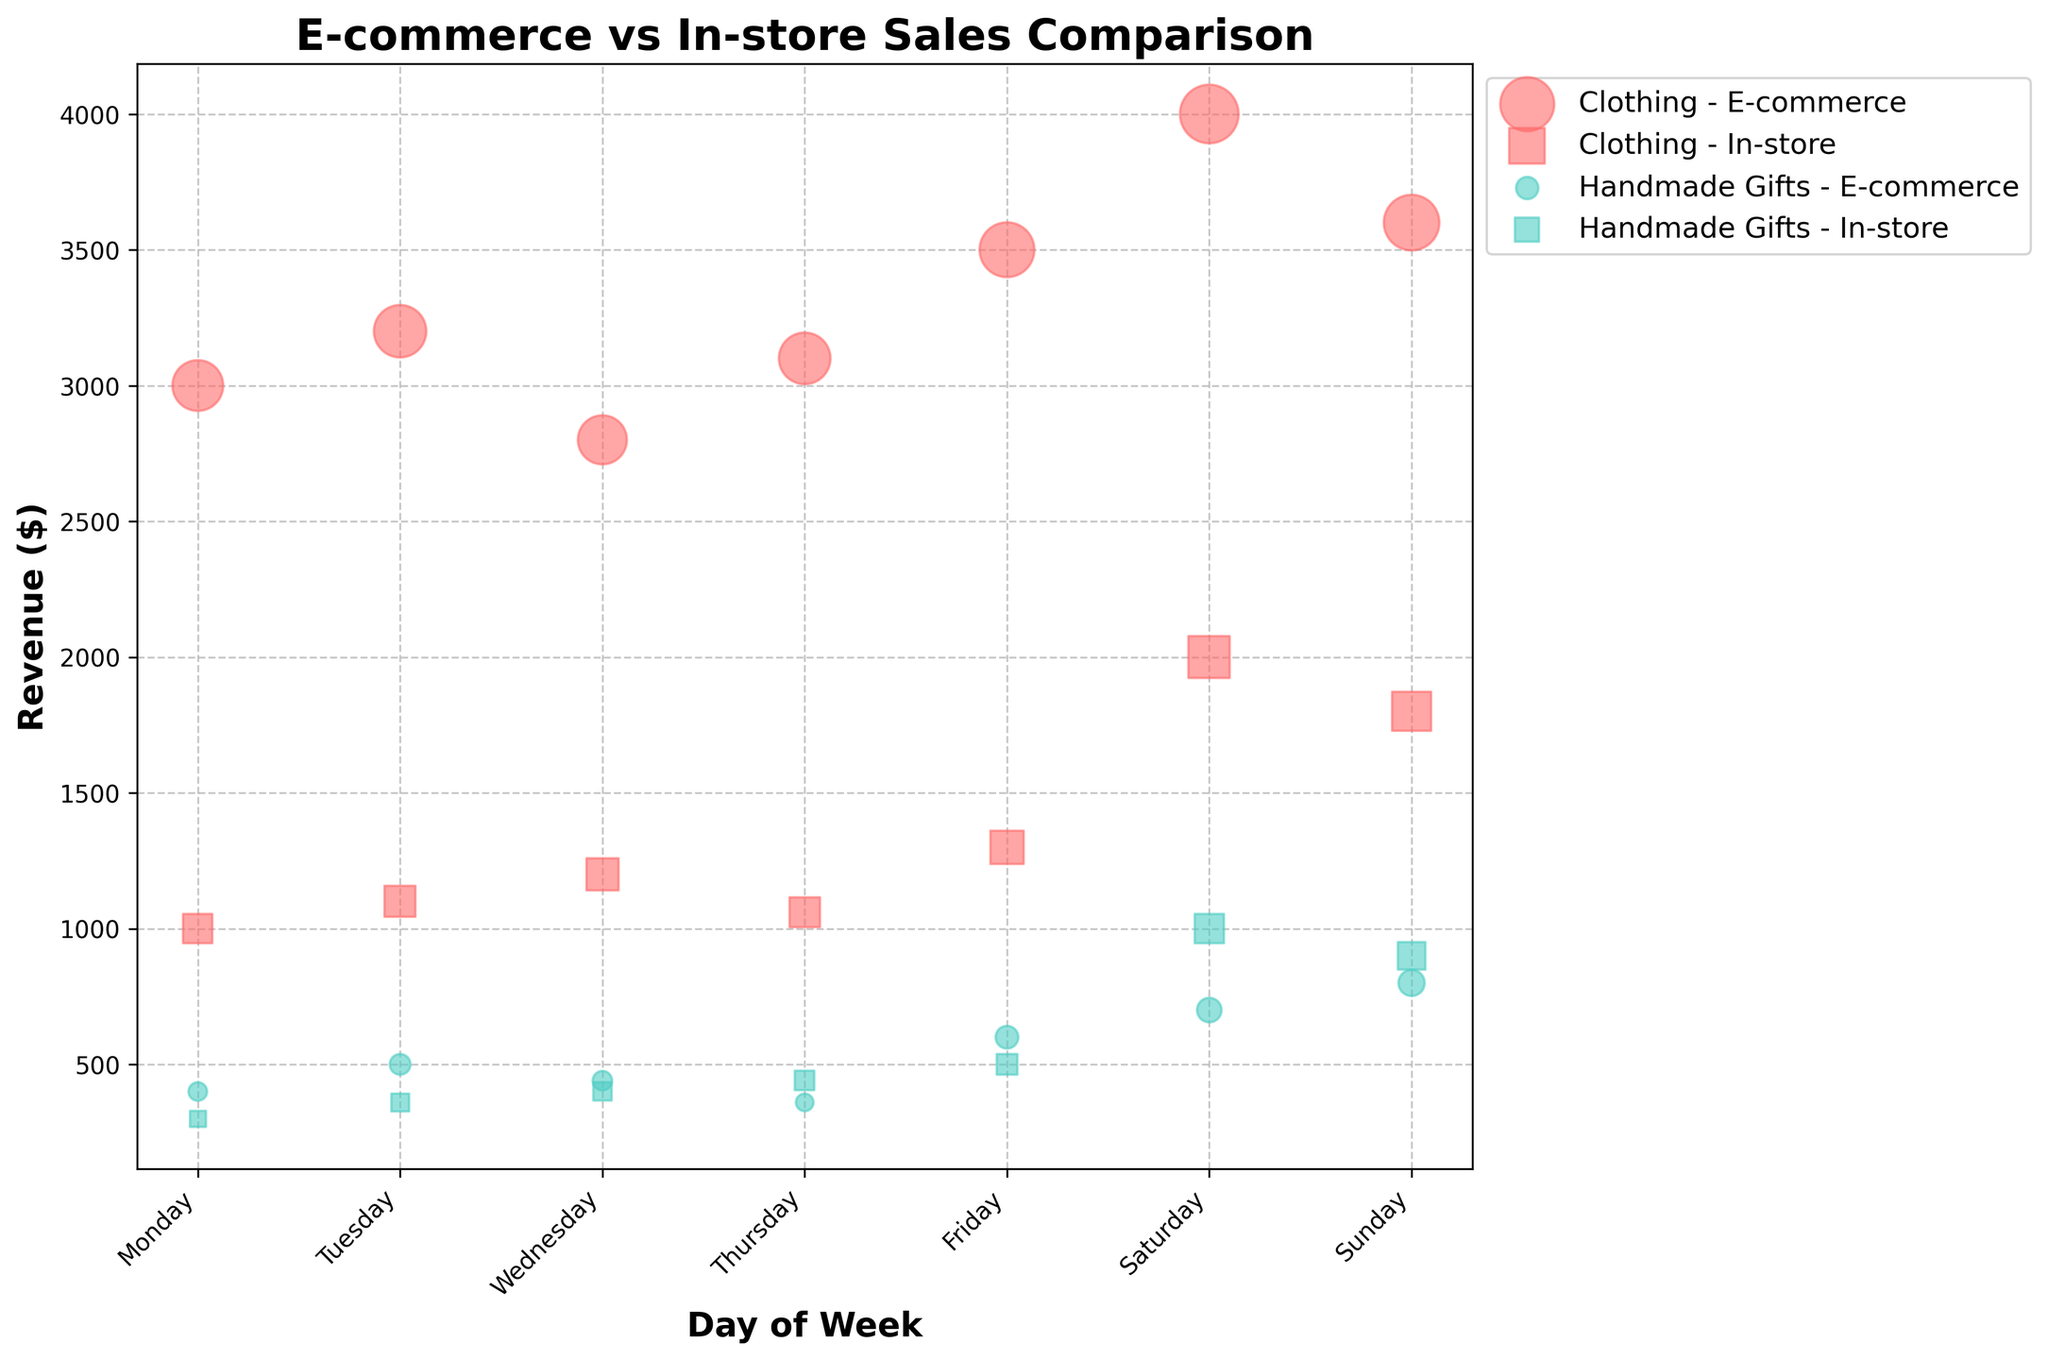What is the title of the figure? The title of the figure is displayed at the top and provides a general description of what the chart represents. In this case, it states "E-commerce vs In-store Sales Comparison".
Answer: E-commerce vs In-store Sales Comparison Which category has the highest revenue on Saturday for E-commerce? To determine this, look for the bubble with the highest vertical position under the "Saturday" label, with the color corresponding to E-commerce. The highest bubble is colored for Clothing.
Answer: Clothing How many items sold for Handmade Gifts through In-store on Sunday? Identify the bubble for Handmade Gifts sold In-store on Sunday. Count the number inside or near the bubble which indicates the number of items sold, scaled by size. The bubble shows 45 items.
Answer: 45 items Which day has the highest revenue for In-store purchases in the Clothing category? Compare the heights of the bubbles with the corresponding color and marker for In-store purchases of Clothing over all days. The highest point occurs on Saturday.
Answer: Saturday What is the total revenue generated from E-commerce sales for Handmade Gifts throughout the week? Sum the y-coordinates (revenue) of the E-commerce Handmade Gifts bubbles across all days: \(400 + 500 + 440 + 360 + 600 + 700 + 800\). The total is $3800.
Answer: $3800 On which day of the week do Handmade Gifts have equal revenue for both E-commerce and In-store channels? Look for the day where the heights (revenue) of bubbles for both channels in Handmade Gifts are the same. Only on Monday, both have $400 revenue.
Answer: Monday Which category has more consistent sales in E-commerce in terms of items sold throughout the week? Compare the bubbles' sizes (representing items sold) for both categories across the week. Clothing category has consistent bubble sizes, indicating more consistency in sales.
Answer: Clothing How does the revenue for In-store sales of Clothing on Friday compare to that of E-commerce sales of Handmade Gifts on the same day? Compare the vertical positions of the corresponding bubbles on Friday. In-store Clothing revenue is $1300 and E-commerce Handmade Gifts revenue is $600, so In-store Clothing has higher revenue.
Answer: In-store Clothing is higher What is the difference in the total number of items sold between E-commerce and In-store channels on Saturday? Calculate the total items sold for each channel on Saturday then find their difference: \(200+35\) E-commerce and \(100+50\) In-store. The difference is 235 - 150 = 85.
Answer: 85 